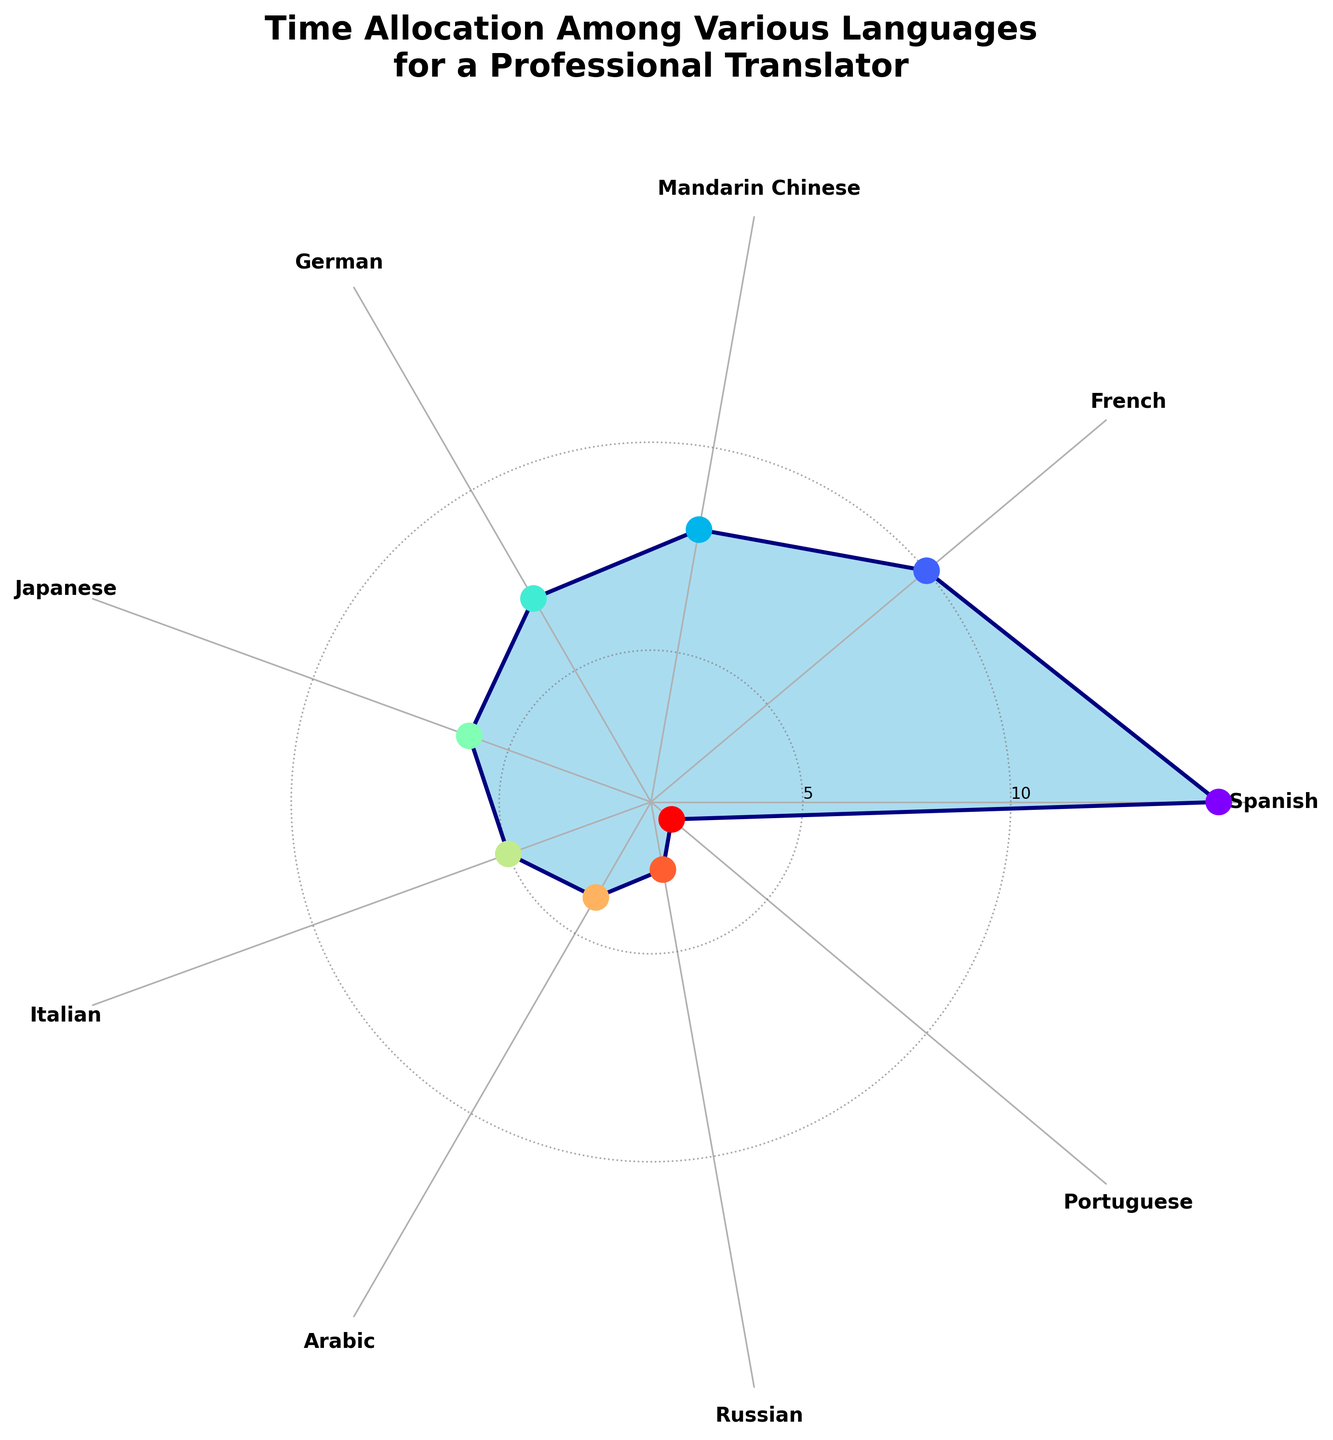What is the title of the chart? The title is located at the top of the chart and reads, "Time Allocation Among Various Languages for a Professional Translator". This clearly indicates that the chart shows how many hours per week a professional translator allocates to learning various languages.
Answer: Time Allocation Among Various Languages for a Professional Translator What language does the translator spend the most time on? To find this, look for the section with the maximum radius in the chart. The outermost data point indicates the language with the highest time allocation, which is labeled as "Spanish" with 15 hours per week.
Answer: Spanish How many languages are being studied for more than 5 hours per week? Identify the sections of the chart that extend beyond the 5-hour mark on the polar plot. From observation: Spanish, French, Mandarin Chinese, German, and Japanese all exceed 5 hours per week.
Answer: 5 What is the difference in time allocation between French and Japanese? Locate the positions for French and Japanese in the chart. French is allocated 10 hours per week, and Japanese is allocated 6. Subtract the smaller value from the larger one: 10 - 6 = 4.
Answer: 4 hours Which language has the smallest time allocation and how many hours does it get? Determine the shortest section within the chart. The segment representing Portuguese has the smallest time allocation, which is 2 hours per week.
Answer: Portuguese, 2 hours How many total hours does the translator spend on Arabic and Russian combined? Look for the hours per week values for Arabic and Russian. Arabic has 4 hours, and Russian has 3. Adding these together: 4 + 3 = 7.
Answer: 7 hours What is the average time spent per language? To find the average, sum all the hours spent on each language and divide by the number of languages. The total is 15 + 10 + 8 + 7 + 6 + 5 + 4 + 3 + 2 = 60 hours. There are 9 languages. So, the average is 60 / 9 ≈ 6.67 hours.
Answer: 6.67 hours Between Mandarin Chinese and German, which language does the translator allocate more time to and by how much? Look at the chart to find the values for Mandarin Chinese (8 hours) and German (7 hours). Mandarin Chinese has more allocated time, exceeding German by 8 - 7 = 1 hour.
Answer: Mandarin Chinese, 1 hour What is the median number of hours allocated among all languages? List the allocation hours in ascending order: 2, 3, 4, 5, 6, 7, 8, 10, 15. The median value is the middle number, so it is 6.
Answer: 6 hours 